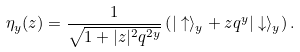Convert formula to latex. <formula><loc_0><loc_0><loc_500><loc_500>\eta _ { y } ( z ) = \frac { 1 } { \sqrt { 1 + | z | ^ { 2 } q ^ { 2 y } } } \left ( | \uparrow \rangle _ { y } + z q ^ { y } | \downarrow \rangle _ { y } \right ) .</formula> 